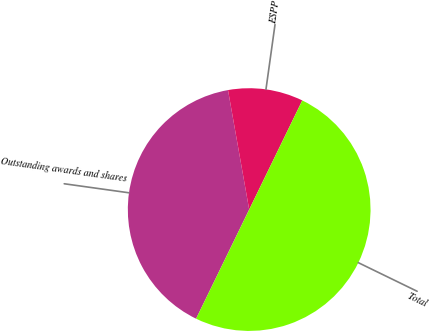Convert chart. <chart><loc_0><loc_0><loc_500><loc_500><pie_chart><fcel>Outstanding awards and shares<fcel>ESPP<fcel>Total<nl><fcel>40.0%<fcel>10.0%<fcel>50.0%<nl></chart> 